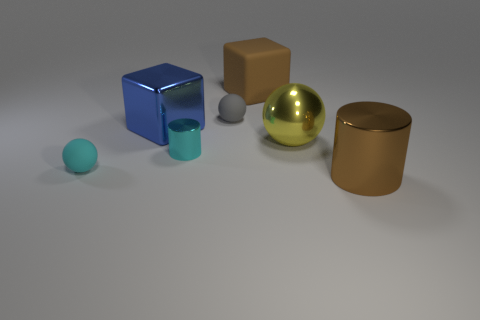What is the large cylinder made of?
Provide a short and direct response. Metal. Do the brown cylinder and the tiny cyan ball that is left of the big brown rubber block have the same material?
Provide a succinct answer. No. Is there anything else of the same color as the rubber block?
Offer a very short reply. Yes. There is a yellow metallic sphere behind the rubber sphere that is in front of the gray sphere; are there any big things in front of it?
Offer a very short reply. Yes. What color is the small shiny object?
Offer a terse response. Cyan. There is a cyan rubber ball; are there any cyan shiny cylinders on the right side of it?
Your answer should be very brief. Yes. Is the shape of the yellow object the same as the small gray matte object that is on the left side of the big yellow shiny sphere?
Ensure brevity in your answer.  Yes. How many other objects are the same material as the small cyan cylinder?
Provide a succinct answer. 3. What color is the rubber object that is in front of the matte ball right of the tiny matte thing in front of the gray sphere?
Keep it short and to the point. Cyan. There is a large metal thing to the left of the cylinder that is behind the large metallic cylinder; what shape is it?
Make the answer very short. Cube. 